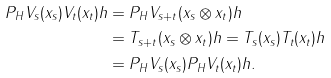Convert formula to latex. <formula><loc_0><loc_0><loc_500><loc_500>P _ { H } V _ { s } ( x _ { s } ) V _ { t } ( x _ { t } ) h & = P _ { H } V _ { s + t } ( x _ { s } \otimes x _ { t } ) h \\ & = T _ { s + t } ( x _ { s } \otimes x _ { t } ) h = T _ { s } ( x _ { s } ) T _ { t } ( x _ { t } ) h \\ & = P _ { H } V _ { s } ( x _ { s } ) P _ { H } V _ { t } ( x _ { t } ) h .</formula> 